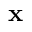<formula> <loc_0><loc_0><loc_500><loc_500>x</formula> 